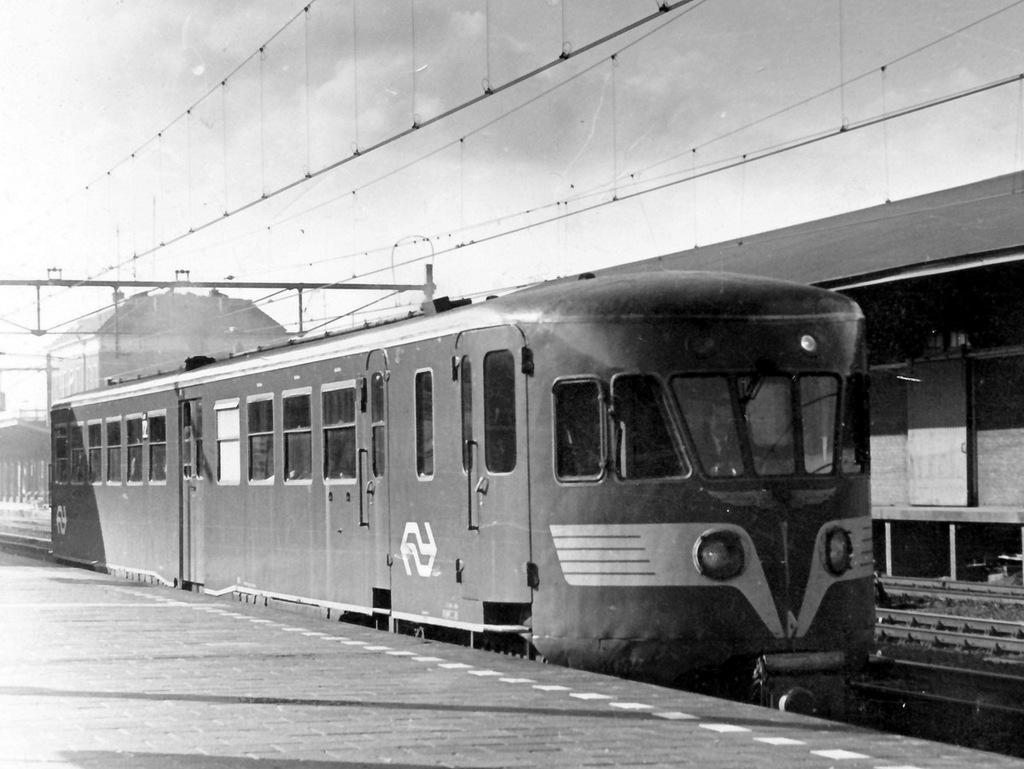Please provide a concise description of this image. This is a black and white image. There is a train on a railway track. There are wires at the top and it looks like a building at the back. 